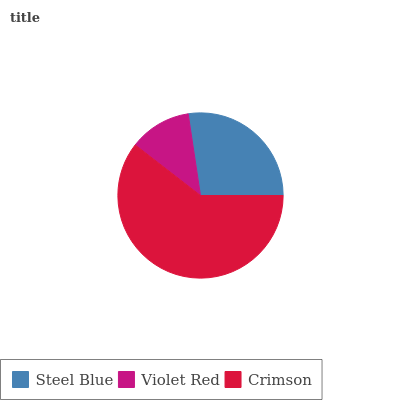Is Violet Red the minimum?
Answer yes or no. Yes. Is Crimson the maximum?
Answer yes or no. Yes. Is Crimson the minimum?
Answer yes or no. No. Is Violet Red the maximum?
Answer yes or no. No. Is Crimson greater than Violet Red?
Answer yes or no. Yes. Is Violet Red less than Crimson?
Answer yes or no. Yes. Is Violet Red greater than Crimson?
Answer yes or no. No. Is Crimson less than Violet Red?
Answer yes or no. No. Is Steel Blue the high median?
Answer yes or no. Yes. Is Steel Blue the low median?
Answer yes or no. Yes. Is Violet Red the high median?
Answer yes or no. No. Is Violet Red the low median?
Answer yes or no. No. 